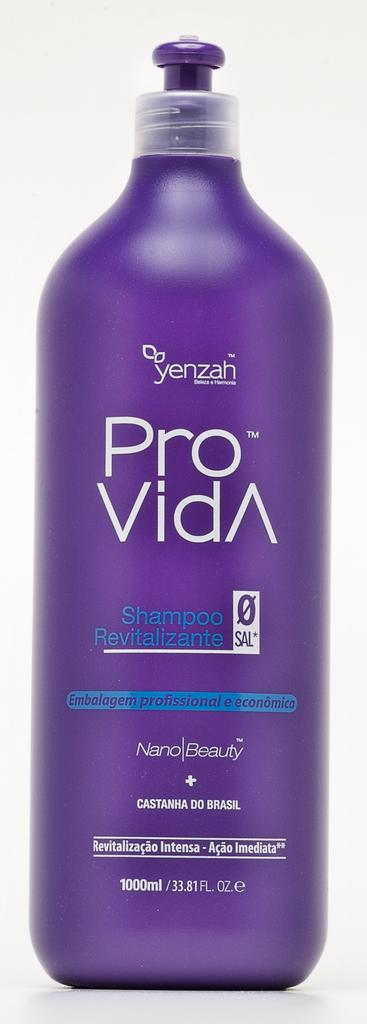Provide a one-sentence caption for the provided image. Purple bottle of Pro Vida by Yenzah in front of a white background. 